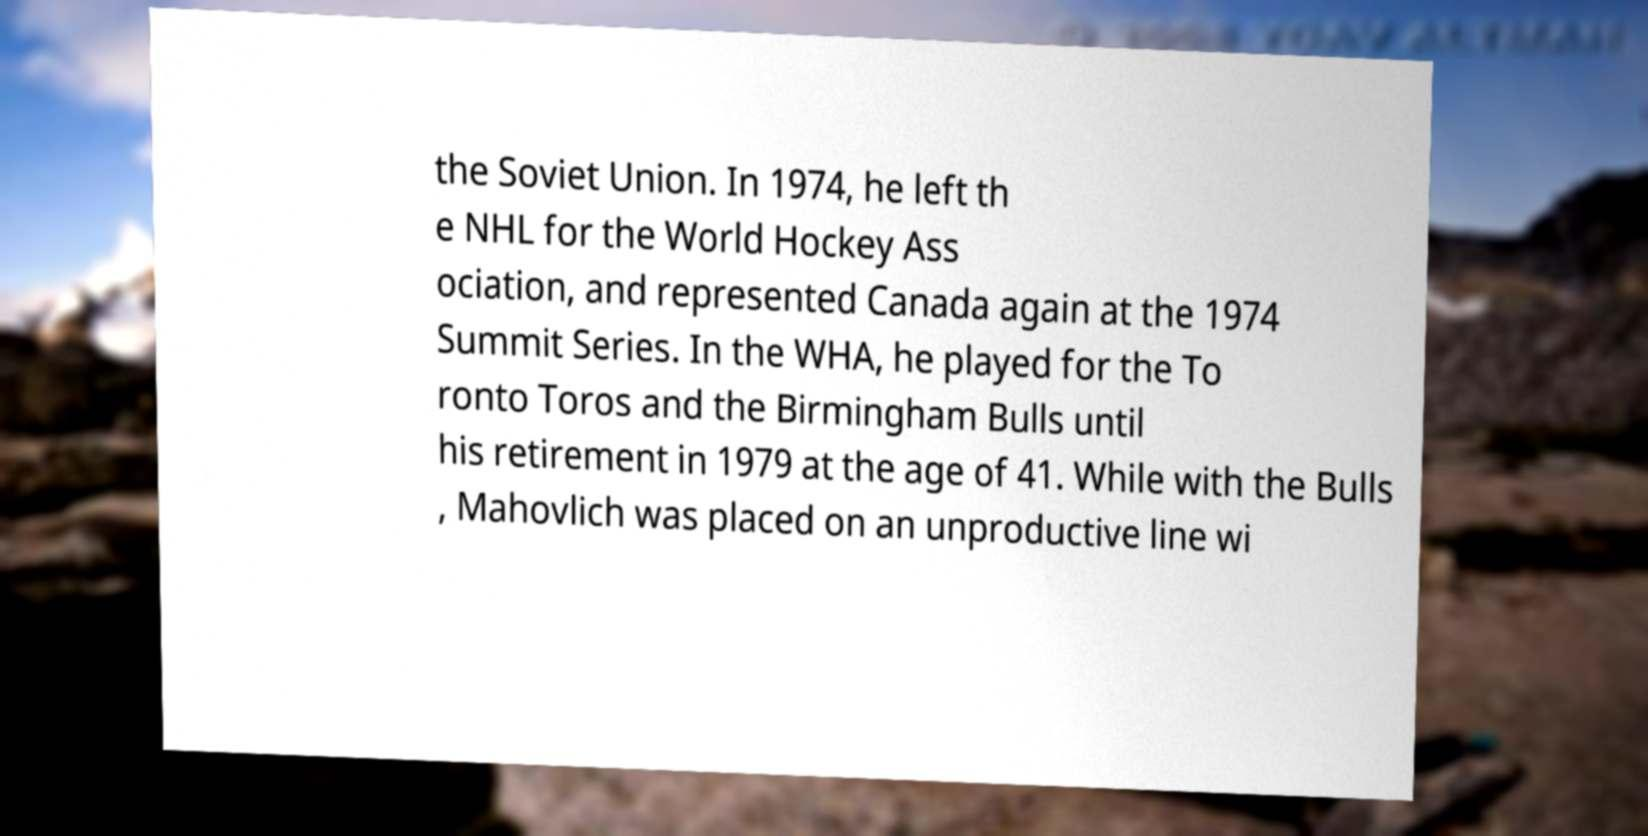Could you assist in decoding the text presented in this image and type it out clearly? the Soviet Union. In 1974, he left th e NHL for the World Hockey Ass ociation, and represented Canada again at the 1974 Summit Series. In the WHA, he played for the To ronto Toros and the Birmingham Bulls until his retirement in 1979 at the age of 41. While with the Bulls , Mahovlich was placed on an unproductive line wi 